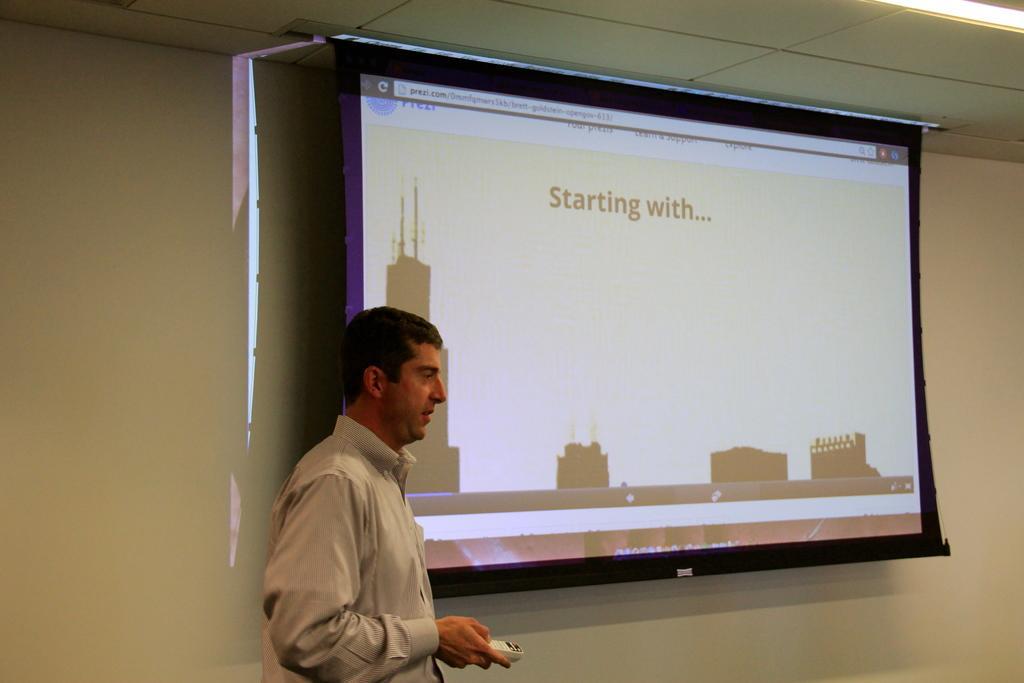Can you describe this image briefly? This picture is clicked in the conference hall. The man in the white shirt is holding a remote in his hand. Beside him, we see a projector screen with some text displayed. Behind that, we see a white wall. At the top of the picture, we see the ceiling of the room. 